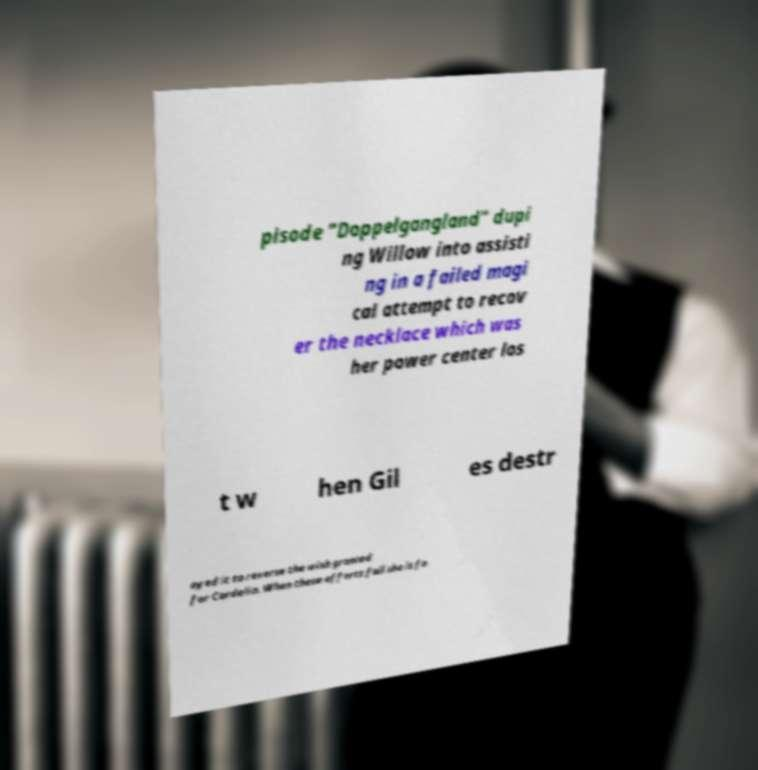Please read and relay the text visible in this image. What does it say? pisode "Doppelgangland" dupi ng Willow into assisti ng in a failed magi cal attempt to recov er the necklace which was her power center los t w hen Gil es destr oyed it to reverse the wish granted for Cordelia. When these efforts fail she is fo 